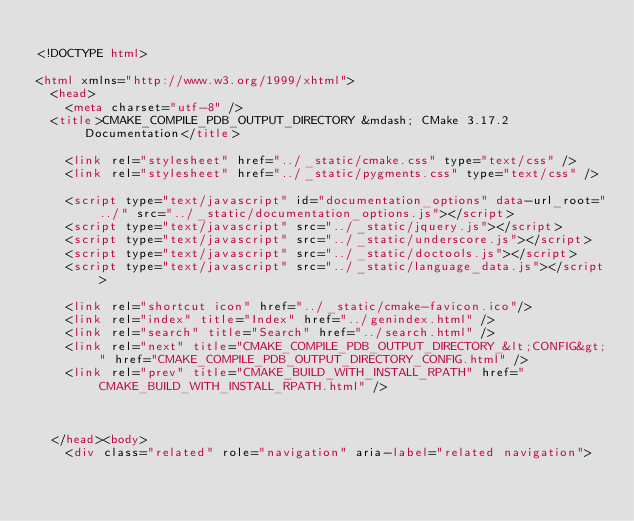Convert code to text. <code><loc_0><loc_0><loc_500><loc_500><_HTML_>
<!DOCTYPE html>

<html xmlns="http://www.w3.org/1999/xhtml">
  <head>
    <meta charset="utf-8" />
  <title>CMAKE_COMPILE_PDB_OUTPUT_DIRECTORY &mdash; CMake 3.17.2 Documentation</title>

    <link rel="stylesheet" href="../_static/cmake.css" type="text/css" />
    <link rel="stylesheet" href="../_static/pygments.css" type="text/css" />
    
    <script type="text/javascript" id="documentation_options" data-url_root="../" src="../_static/documentation_options.js"></script>
    <script type="text/javascript" src="../_static/jquery.js"></script>
    <script type="text/javascript" src="../_static/underscore.js"></script>
    <script type="text/javascript" src="../_static/doctools.js"></script>
    <script type="text/javascript" src="../_static/language_data.js"></script>
    
    <link rel="shortcut icon" href="../_static/cmake-favicon.ico"/>
    <link rel="index" title="Index" href="../genindex.html" />
    <link rel="search" title="Search" href="../search.html" />
    <link rel="next" title="CMAKE_COMPILE_PDB_OUTPUT_DIRECTORY_&lt;CONFIG&gt;" href="CMAKE_COMPILE_PDB_OUTPUT_DIRECTORY_CONFIG.html" />
    <link rel="prev" title="CMAKE_BUILD_WITH_INSTALL_RPATH" href="CMAKE_BUILD_WITH_INSTALL_RPATH.html" />
  
 

  </head><body>
    <div class="related" role="navigation" aria-label="related navigation"></code> 